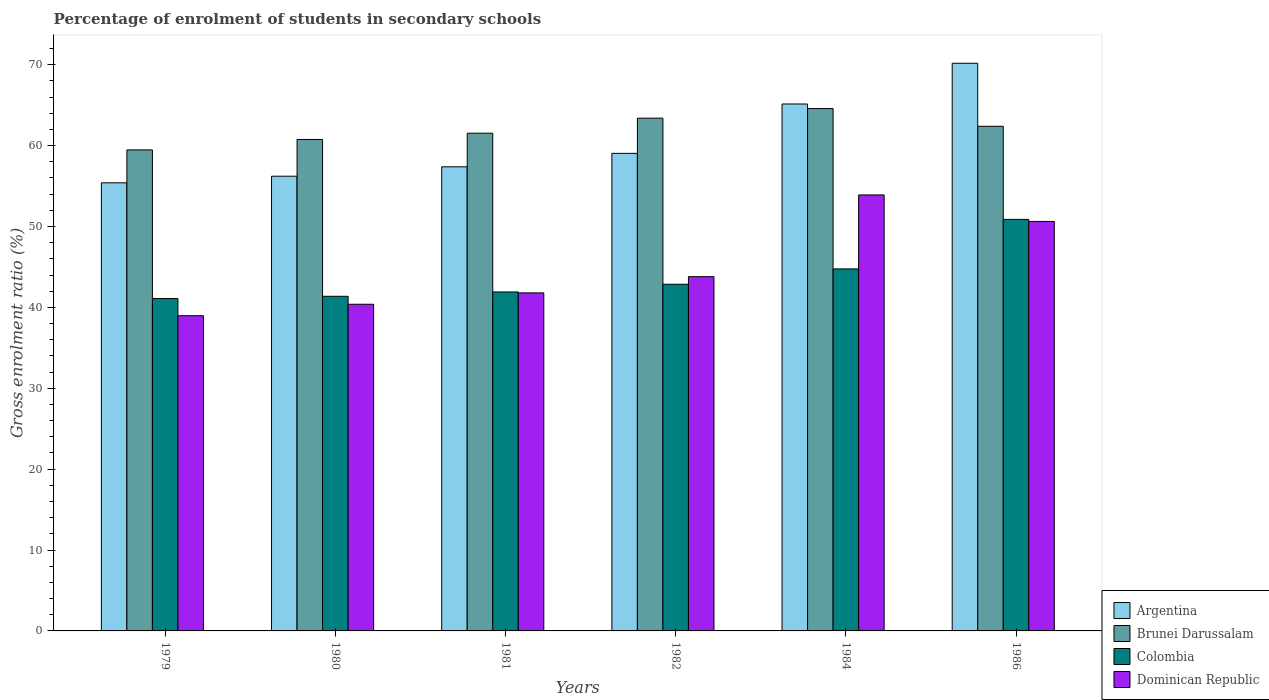How many different coloured bars are there?
Offer a very short reply. 4. Are the number of bars on each tick of the X-axis equal?
Keep it short and to the point. Yes. How many bars are there on the 2nd tick from the left?
Provide a short and direct response. 4. What is the label of the 1st group of bars from the left?
Make the answer very short. 1979. In how many cases, is the number of bars for a given year not equal to the number of legend labels?
Offer a terse response. 0. What is the percentage of students enrolled in secondary schools in Argentina in 1982?
Offer a very short reply. 59.05. Across all years, what is the maximum percentage of students enrolled in secondary schools in Colombia?
Offer a very short reply. 50.88. Across all years, what is the minimum percentage of students enrolled in secondary schools in Brunei Darussalam?
Keep it short and to the point. 59.47. In which year was the percentage of students enrolled in secondary schools in Dominican Republic maximum?
Offer a terse response. 1984. In which year was the percentage of students enrolled in secondary schools in Argentina minimum?
Your answer should be very brief. 1979. What is the total percentage of students enrolled in secondary schools in Argentina in the graph?
Your answer should be very brief. 363.38. What is the difference between the percentage of students enrolled in secondary schools in Brunei Darussalam in 1981 and that in 1984?
Make the answer very short. -3.05. What is the difference between the percentage of students enrolled in secondary schools in Argentina in 1986 and the percentage of students enrolled in secondary schools in Brunei Darussalam in 1980?
Offer a terse response. 9.42. What is the average percentage of students enrolled in secondary schools in Argentina per year?
Give a very brief answer. 60.56. In the year 1984, what is the difference between the percentage of students enrolled in secondary schools in Dominican Republic and percentage of students enrolled in secondary schools in Colombia?
Your answer should be compact. 9.14. What is the ratio of the percentage of students enrolled in secondary schools in Argentina in 1980 to that in 1981?
Keep it short and to the point. 0.98. Is the difference between the percentage of students enrolled in secondary schools in Dominican Republic in 1984 and 1986 greater than the difference between the percentage of students enrolled in secondary schools in Colombia in 1984 and 1986?
Provide a short and direct response. Yes. What is the difference between the highest and the second highest percentage of students enrolled in secondary schools in Dominican Republic?
Make the answer very short. 3.28. What is the difference between the highest and the lowest percentage of students enrolled in secondary schools in Dominican Republic?
Your answer should be very brief. 14.93. In how many years, is the percentage of students enrolled in secondary schools in Colombia greater than the average percentage of students enrolled in secondary schools in Colombia taken over all years?
Provide a short and direct response. 2. Is it the case that in every year, the sum of the percentage of students enrolled in secondary schools in Brunei Darussalam and percentage of students enrolled in secondary schools in Argentina is greater than the sum of percentage of students enrolled in secondary schools in Dominican Republic and percentage of students enrolled in secondary schools in Colombia?
Ensure brevity in your answer.  Yes. What does the 1st bar from the right in 1984 represents?
Give a very brief answer. Dominican Republic. How many bars are there?
Provide a succinct answer. 24. Are all the bars in the graph horizontal?
Give a very brief answer. No. How many years are there in the graph?
Give a very brief answer. 6. Does the graph contain any zero values?
Your answer should be very brief. No. How many legend labels are there?
Provide a short and direct response. 4. How are the legend labels stacked?
Ensure brevity in your answer.  Vertical. What is the title of the graph?
Give a very brief answer. Percentage of enrolment of students in secondary schools. What is the Gross enrolment ratio (%) of Argentina in 1979?
Ensure brevity in your answer.  55.4. What is the Gross enrolment ratio (%) of Brunei Darussalam in 1979?
Your answer should be compact. 59.47. What is the Gross enrolment ratio (%) in Colombia in 1979?
Provide a short and direct response. 41.1. What is the Gross enrolment ratio (%) in Dominican Republic in 1979?
Provide a succinct answer. 38.97. What is the Gross enrolment ratio (%) in Argentina in 1980?
Your answer should be very brief. 56.22. What is the Gross enrolment ratio (%) of Brunei Darussalam in 1980?
Your answer should be very brief. 60.76. What is the Gross enrolment ratio (%) of Colombia in 1980?
Ensure brevity in your answer.  41.37. What is the Gross enrolment ratio (%) in Dominican Republic in 1980?
Make the answer very short. 40.39. What is the Gross enrolment ratio (%) in Argentina in 1981?
Offer a very short reply. 57.38. What is the Gross enrolment ratio (%) of Brunei Darussalam in 1981?
Offer a terse response. 61.54. What is the Gross enrolment ratio (%) in Colombia in 1981?
Offer a terse response. 41.91. What is the Gross enrolment ratio (%) in Dominican Republic in 1981?
Your answer should be compact. 41.79. What is the Gross enrolment ratio (%) of Argentina in 1982?
Your answer should be very brief. 59.05. What is the Gross enrolment ratio (%) in Brunei Darussalam in 1982?
Ensure brevity in your answer.  63.4. What is the Gross enrolment ratio (%) in Colombia in 1982?
Make the answer very short. 42.86. What is the Gross enrolment ratio (%) in Dominican Republic in 1982?
Offer a terse response. 43.8. What is the Gross enrolment ratio (%) of Argentina in 1984?
Provide a succinct answer. 65.15. What is the Gross enrolment ratio (%) in Brunei Darussalam in 1984?
Your response must be concise. 64.59. What is the Gross enrolment ratio (%) in Colombia in 1984?
Keep it short and to the point. 44.76. What is the Gross enrolment ratio (%) of Dominican Republic in 1984?
Offer a terse response. 53.9. What is the Gross enrolment ratio (%) of Argentina in 1986?
Offer a very short reply. 70.18. What is the Gross enrolment ratio (%) of Brunei Darussalam in 1986?
Your answer should be compact. 62.39. What is the Gross enrolment ratio (%) of Colombia in 1986?
Provide a succinct answer. 50.88. What is the Gross enrolment ratio (%) in Dominican Republic in 1986?
Provide a succinct answer. 50.63. Across all years, what is the maximum Gross enrolment ratio (%) of Argentina?
Give a very brief answer. 70.18. Across all years, what is the maximum Gross enrolment ratio (%) in Brunei Darussalam?
Keep it short and to the point. 64.59. Across all years, what is the maximum Gross enrolment ratio (%) of Colombia?
Provide a succinct answer. 50.88. Across all years, what is the maximum Gross enrolment ratio (%) in Dominican Republic?
Make the answer very short. 53.9. Across all years, what is the minimum Gross enrolment ratio (%) of Argentina?
Your answer should be compact. 55.4. Across all years, what is the minimum Gross enrolment ratio (%) in Brunei Darussalam?
Your response must be concise. 59.47. Across all years, what is the minimum Gross enrolment ratio (%) in Colombia?
Make the answer very short. 41.1. Across all years, what is the minimum Gross enrolment ratio (%) in Dominican Republic?
Ensure brevity in your answer.  38.97. What is the total Gross enrolment ratio (%) of Argentina in the graph?
Offer a terse response. 363.38. What is the total Gross enrolment ratio (%) of Brunei Darussalam in the graph?
Give a very brief answer. 372.14. What is the total Gross enrolment ratio (%) of Colombia in the graph?
Your response must be concise. 262.88. What is the total Gross enrolment ratio (%) in Dominican Republic in the graph?
Provide a succinct answer. 269.48. What is the difference between the Gross enrolment ratio (%) in Argentina in 1979 and that in 1980?
Keep it short and to the point. -0.82. What is the difference between the Gross enrolment ratio (%) in Brunei Darussalam in 1979 and that in 1980?
Your response must be concise. -1.29. What is the difference between the Gross enrolment ratio (%) in Colombia in 1979 and that in 1980?
Make the answer very short. -0.28. What is the difference between the Gross enrolment ratio (%) in Dominican Republic in 1979 and that in 1980?
Your answer should be very brief. -1.42. What is the difference between the Gross enrolment ratio (%) in Argentina in 1979 and that in 1981?
Offer a terse response. -1.98. What is the difference between the Gross enrolment ratio (%) in Brunei Darussalam in 1979 and that in 1981?
Your answer should be compact. -2.07. What is the difference between the Gross enrolment ratio (%) in Colombia in 1979 and that in 1981?
Make the answer very short. -0.81. What is the difference between the Gross enrolment ratio (%) of Dominican Republic in 1979 and that in 1981?
Keep it short and to the point. -2.82. What is the difference between the Gross enrolment ratio (%) in Argentina in 1979 and that in 1982?
Offer a very short reply. -3.64. What is the difference between the Gross enrolment ratio (%) in Brunei Darussalam in 1979 and that in 1982?
Make the answer very short. -3.93. What is the difference between the Gross enrolment ratio (%) of Colombia in 1979 and that in 1982?
Offer a very short reply. -1.77. What is the difference between the Gross enrolment ratio (%) of Dominican Republic in 1979 and that in 1982?
Your response must be concise. -4.83. What is the difference between the Gross enrolment ratio (%) of Argentina in 1979 and that in 1984?
Offer a very short reply. -9.74. What is the difference between the Gross enrolment ratio (%) of Brunei Darussalam in 1979 and that in 1984?
Give a very brief answer. -5.12. What is the difference between the Gross enrolment ratio (%) of Colombia in 1979 and that in 1984?
Give a very brief answer. -3.66. What is the difference between the Gross enrolment ratio (%) of Dominican Republic in 1979 and that in 1984?
Keep it short and to the point. -14.93. What is the difference between the Gross enrolment ratio (%) in Argentina in 1979 and that in 1986?
Your response must be concise. -14.78. What is the difference between the Gross enrolment ratio (%) in Brunei Darussalam in 1979 and that in 1986?
Your response must be concise. -2.92. What is the difference between the Gross enrolment ratio (%) of Colombia in 1979 and that in 1986?
Make the answer very short. -9.79. What is the difference between the Gross enrolment ratio (%) of Dominican Republic in 1979 and that in 1986?
Make the answer very short. -11.66. What is the difference between the Gross enrolment ratio (%) of Argentina in 1980 and that in 1981?
Offer a terse response. -1.16. What is the difference between the Gross enrolment ratio (%) in Brunei Darussalam in 1980 and that in 1981?
Make the answer very short. -0.78. What is the difference between the Gross enrolment ratio (%) in Colombia in 1980 and that in 1981?
Keep it short and to the point. -0.53. What is the difference between the Gross enrolment ratio (%) in Dominican Republic in 1980 and that in 1981?
Ensure brevity in your answer.  -1.41. What is the difference between the Gross enrolment ratio (%) of Argentina in 1980 and that in 1982?
Your response must be concise. -2.83. What is the difference between the Gross enrolment ratio (%) of Brunei Darussalam in 1980 and that in 1982?
Offer a terse response. -2.63. What is the difference between the Gross enrolment ratio (%) in Colombia in 1980 and that in 1982?
Your answer should be very brief. -1.49. What is the difference between the Gross enrolment ratio (%) in Dominican Republic in 1980 and that in 1982?
Provide a succinct answer. -3.41. What is the difference between the Gross enrolment ratio (%) in Argentina in 1980 and that in 1984?
Offer a very short reply. -8.93. What is the difference between the Gross enrolment ratio (%) of Brunei Darussalam in 1980 and that in 1984?
Provide a short and direct response. -3.82. What is the difference between the Gross enrolment ratio (%) in Colombia in 1980 and that in 1984?
Your response must be concise. -3.39. What is the difference between the Gross enrolment ratio (%) of Dominican Republic in 1980 and that in 1984?
Make the answer very short. -13.52. What is the difference between the Gross enrolment ratio (%) of Argentina in 1980 and that in 1986?
Provide a short and direct response. -13.96. What is the difference between the Gross enrolment ratio (%) of Brunei Darussalam in 1980 and that in 1986?
Offer a terse response. -1.63. What is the difference between the Gross enrolment ratio (%) of Colombia in 1980 and that in 1986?
Offer a terse response. -9.51. What is the difference between the Gross enrolment ratio (%) of Dominican Republic in 1980 and that in 1986?
Make the answer very short. -10.24. What is the difference between the Gross enrolment ratio (%) of Argentina in 1981 and that in 1982?
Your response must be concise. -1.66. What is the difference between the Gross enrolment ratio (%) of Brunei Darussalam in 1981 and that in 1982?
Provide a short and direct response. -1.86. What is the difference between the Gross enrolment ratio (%) in Colombia in 1981 and that in 1982?
Your response must be concise. -0.96. What is the difference between the Gross enrolment ratio (%) of Dominican Republic in 1981 and that in 1982?
Offer a terse response. -2.01. What is the difference between the Gross enrolment ratio (%) in Argentina in 1981 and that in 1984?
Your response must be concise. -7.77. What is the difference between the Gross enrolment ratio (%) of Brunei Darussalam in 1981 and that in 1984?
Provide a short and direct response. -3.05. What is the difference between the Gross enrolment ratio (%) of Colombia in 1981 and that in 1984?
Make the answer very short. -2.85. What is the difference between the Gross enrolment ratio (%) of Dominican Republic in 1981 and that in 1984?
Keep it short and to the point. -12.11. What is the difference between the Gross enrolment ratio (%) in Argentina in 1981 and that in 1986?
Make the answer very short. -12.8. What is the difference between the Gross enrolment ratio (%) of Brunei Darussalam in 1981 and that in 1986?
Offer a very short reply. -0.85. What is the difference between the Gross enrolment ratio (%) of Colombia in 1981 and that in 1986?
Keep it short and to the point. -8.97. What is the difference between the Gross enrolment ratio (%) in Dominican Republic in 1981 and that in 1986?
Give a very brief answer. -8.83. What is the difference between the Gross enrolment ratio (%) of Argentina in 1982 and that in 1984?
Offer a very short reply. -6.1. What is the difference between the Gross enrolment ratio (%) in Brunei Darussalam in 1982 and that in 1984?
Your response must be concise. -1.19. What is the difference between the Gross enrolment ratio (%) in Colombia in 1982 and that in 1984?
Provide a succinct answer. -1.9. What is the difference between the Gross enrolment ratio (%) of Dominican Republic in 1982 and that in 1984?
Give a very brief answer. -10.11. What is the difference between the Gross enrolment ratio (%) of Argentina in 1982 and that in 1986?
Your response must be concise. -11.14. What is the difference between the Gross enrolment ratio (%) of Colombia in 1982 and that in 1986?
Keep it short and to the point. -8.02. What is the difference between the Gross enrolment ratio (%) of Dominican Republic in 1982 and that in 1986?
Your answer should be compact. -6.83. What is the difference between the Gross enrolment ratio (%) in Argentina in 1984 and that in 1986?
Keep it short and to the point. -5.04. What is the difference between the Gross enrolment ratio (%) of Brunei Darussalam in 1984 and that in 1986?
Your response must be concise. 2.2. What is the difference between the Gross enrolment ratio (%) of Colombia in 1984 and that in 1986?
Your answer should be very brief. -6.12. What is the difference between the Gross enrolment ratio (%) of Dominican Republic in 1984 and that in 1986?
Your answer should be very brief. 3.28. What is the difference between the Gross enrolment ratio (%) in Argentina in 1979 and the Gross enrolment ratio (%) in Brunei Darussalam in 1980?
Your answer should be compact. -5.36. What is the difference between the Gross enrolment ratio (%) in Argentina in 1979 and the Gross enrolment ratio (%) in Colombia in 1980?
Keep it short and to the point. 14.03. What is the difference between the Gross enrolment ratio (%) in Argentina in 1979 and the Gross enrolment ratio (%) in Dominican Republic in 1980?
Your answer should be very brief. 15.02. What is the difference between the Gross enrolment ratio (%) of Brunei Darussalam in 1979 and the Gross enrolment ratio (%) of Colombia in 1980?
Keep it short and to the point. 18.1. What is the difference between the Gross enrolment ratio (%) of Brunei Darussalam in 1979 and the Gross enrolment ratio (%) of Dominican Republic in 1980?
Provide a succinct answer. 19.08. What is the difference between the Gross enrolment ratio (%) in Colombia in 1979 and the Gross enrolment ratio (%) in Dominican Republic in 1980?
Make the answer very short. 0.71. What is the difference between the Gross enrolment ratio (%) of Argentina in 1979 and the Gross enrolment ratio (%) of Brunei Darussalam in 1981?
Your answer should be compact. -6.14. What is the difference between the Gross enrolment ratio (%) of Argentina in 1979 and the Gross enrolment ratio (%) of Colombia in 1981?
Your answer should be very brief. 13.5. What is the difference between the Gross enrolment ratio (%) in Argentina in 1979 and the Gross enrolment ratio (%) in Dominican Republic in 1981?
Your answer should be compact. 13.61. What is the difference between the Gross enrolment ratio (%) in Brunei Darussalam in 1979 and the Gross enrolment ratio (%) in Colombia in 1981?
Your answer should be compact. 17.56. What is the difference between the Gross enrolment ratio (%) of Brunei Darussalam in 1979 and the Gross enrolment ratio (%) of Dominican Republic in 1981?
Ensure brevity in your answer.  17.68. What is the difference between the Gross enrolment ratio (%) in Colombia in 1979 and the Gross enrolment ratio (%) in Dominican Republic in 1981?
Your answer should be very brief. -0.7. What is the difference between the Gross enrolment ratio (%) of Argentina in 1979 and the Gross enrolment ratio (%) of Brunei Darussalam in 1982?
Your answer should be compact. -7.99. What is the difference between the Gross enrolment ratio (%) in Argentina in 1979 and the Gross enrolment ratio (%) in Colombia in 1982?
Your answer should be very brief. 12.54. What is the difference between the Gross enrolment ratio (%) in Argentina in 1979 and the Gross enrolment ratio (%) in Dominican Republic in 1982?
Provide a succinct answer. 11.61. What is the difference between the Gross enrolment ratio (%) in Brunei Darussalam in 1979 and the Gross enrolment ratio (%) in Colombia in 1982?
Your answer should be very brief. 16.61. What is the difference between the Gross enrolment ratio (%) in Brunei Darussalam in 1979 and the Gross enrolment ratio (%) in Dominican Republic in 1982?
Ensure brevity in your answer.  15.67. What is the difference between the Gross enrolment ratio (%) of Colombia in 1979 and the Gross enrolment ratio (%) of Dominican Republic in 1982?
Offer a terse response. -2.7. What is the difference between the Gross enrolment ratio (%) of Argentina in 1979 and the Gross enrolment ratio (%) of Brunei Darussalam in 1984?
Provide a short and direct response. -9.18. What is the difference between the Gross enrolment ratio (%) in Argentina in 1979 and the Gross enrolment ratio (%) in Colombia in 1984?
Offer a terse response. 10.64. What is the difference between the Gross enrolment ratio (%) in Argentina in 1979 and the Gross enrolment ratio (%) in Dominican Republic in 1984?
Ensure brevity in your answer.  1.5. What is the difference between the Gross enrolment ratio (%) of Brunei Darussalam in 1979 and the Gross enrolment ratio (%) of Colombia in 1984?
Provide a short and direct response. 14.71. What is the difference between the Gross enrolment ratio (%) in Brunei Darussalam in 1979 and the Gross enrolment ratio (%) in Dominican Republic in 1984?
Your answer should be compact. 5.56. What is the difference between the Gross enrolment ratio (%) in Colombia in 1979 and the Gross enrolment ratio (%) in Dominican Republic in 1984?
Provide a succinct answer. -12.81. What is the difference between the Gross enrolment ratio (%) of Argentina in 1979 and the Gross enrolment ratio (%) of Brunei Darussalam in 1986?
Your response must be concise. -6.99. What is the difference between the Gross enrolment ratio (%) of Argentina in 1979 and the Gross enrolment ratio (%) of Colombia in 1986?
Give a very brief answer. 4.52. What is the difference between the Gross enrolment ratio (%) of Argentina in 1979 and the Gross enrolment ratio (%) of Dominican Republic in 1986?
Ensure brevity in your answer.  4.78. What is the difference between the Gross enrolment ratio (%) in Brunei Darussalam in 1979 and the Gross enrolment ratio (%) in Colombia in 1986?
Provide a short and direct response. 8.59. What is the difference between the Gross enrolment ratio (%) of Brunei Darussalam in 1979 and the Gross enrolment ratio (%) of Dominican Republic in 1986?
Give a very brief answer. 8.84. What is the difference between the Gross enrolment ratio (%) of Colombia in 1979 and the Gross enrolment ratio (%) of Dominican Republic in 1986?
Make the answer very short. -9.53. What is the difference between the Gross enrolment ratio (%) of Argentina in 1980 and the Gross enrolment ratio (%) of Brunei Darussalam in 1981?
Offer a very short reply. -5.32. What is the difference between the Gross enrolment ratio (%) in Argentina in 1980 and the Gross enrolment ratio (%) in Colombia in 1981?
Your answer should be very brief. 14.31. What is the difference between the Gross enrolment ratio (%) in Argentina in 1980 and the Gross enrolment ratio (%) in Dominican Republic in 1981?
Your answer should be compact. 14.43. What is the difference between the Gross enrolment ratio (%) in Brunei Darussalam in 1980 and the Gross enrolment ratio (%) in Colombia in 1981?
Provide a short and direct response. 18.85. What is the difference between the Gross enrolment ratio (%) of Brunei Darussalam in 1980 and the Gross enrolment ratio (%) of Dominican Republic in 1981?
Provide a short and direct response. 18.97. What is the difference between the Gross enrolment ratio (%) in Colombia in 1980 and the Gross enrolment ratio (%) in Dominican Republic in 1981?
Give a very brief answer. -0.42. What is the difference between the Gross enrolment ratio (%) of Argentina in 1980 and the Gross enrolment ratio (%) of Brunei Darussalam in 1982?
Ensure brevity in your answer.  -7.18. What is the difference between the Gross enrolment ratio (%) in Argentina in 1980 and the Gross enrolment ratio (%) in Colombia in 1982?
Offer a very short reply. 13.36. What is the difference between the Gross enrolment ratio (%) in Argentina in 1980 and the Gross enrolment ratio (%) in Dominican Republic in 1982?
Your answer should be very brief. 12.42. What is the difference between the Gross enrolment ratio (%) of Brunei Darussalam in 1980 and the Gross enrolment ratio (%) of Colombia in 1982?
Make the answer very short. 17.9. What is the difference between the Gross enrolment ratio (%) in Brunei Darussalam in 1980 and the Gross enrolment ratio (%) in Dominican Republic in 1982?
Make the answer very short. 16.96. What is the difference between the Gross enrolment ratio (%) of Colombia in 1980 and the Gross enrolment ratio (%) of Dominican Republic in 1982?
Make the answer very short. -2.43. What is the difference between the Gross enrolment ratio (%) of Argentina in 1980 and the Gross enrolment ratio (%) of Brunei Darussalam in 1984?
Your answer should be very brief. -8.37. What is the difference between the Gross enrolment ratio (%) of Argentina in 1980 and the Gross enrolment ratio (%) of Colombia in 1984?
Your answer should be compact. 11.46. What is the difference between the Gross enrolment ratio (%) in Argentina in 1980 and the Gross enrolment ratio (%) in Dominican Republic in 1984?
Offer a terse response. 2.31. What is the difference between the Gross enrolment ratio (%) of Brunei Darussalam in 1980 and the Gross enrolment ratio (%) of Colombia in 1984?
Offer a terse response. 16. What is the difference between the Gross enrolment ratio (%) of Brunei Darussalam in 1980 and the Gross enrolment ratio (%) of Dominican Republic in 1984?
Ensure brevity in your answer.  6.86. What is the difference between the Gross enrolment ratio (%) in Colombia in 1980 and the Gross enrolment ratio (%) in Dominican Republic in 1984?
Offer a very short reply. -12.53. What is the difference between the Gross enrolment ratio (%) of Argentina in 1980 and the Gross enrolment ratio (%) of Brunei Darussalam in 1986?
Your answer should be compact. -6.17. What is the difference between the Gross enrolment ratio (%) in Argentina in 1980 and the Gross enrolment ratio (%) in Colombia in 1986?
Your answer should be compact. 5.34. What is the difference between the Gross enrolment ratio (%) in Argentina in 1980 and the Gross enrolment ratio (%) in Dominican Republic in 1986?
Provide a succinct answer. 5.59. What is the difference between the Gross enrolment ratio (%) of Brunei Darussalam in 1980 and the Gross enrolment ratio (%) of Colombia in 1986?
Provide a succinct answer. 9.88. What is the difference between the Gross enrolment ratio (%) of Brunei Darussalam in 1980 and the Gross enrolment ratio (%) of Dominican Republic in 1986?
Offer a very short reply. 10.14. What is the difference between the Gross enrolment ratio (%) in Colombia in 1980 and the Gross enrolment ratio (%) in Dominican Republic in 1986?
Provide a short and direct response. -9.25. What is the difference between the Gross enrolment ratio (%) of Argentina in 1981 and the Gross enrolment ratio (%) of Brunei Darussalam in 1982?
Provide a succinct answer. -6.01. What is the difference between the Gross enrolment ratio (%) in Argentina in 1981 and the Gross enrolment ratio (%) in Colombia in 1982?
Give a very brief answer. 14.52. What is the difference between the Gross enrolment ratio (%) of Argentina in 1981 and the Gross enrolment ratio (%) of Dominican Republic in 1982?
Your answer should be very brief. 13.58. What is the difference between the Gross enrolment ratio (%) in Brunei Darussalam in 1981 and the Gross enrolment ratio (%) in Colombia in 1982?
Keep it short and to the point. 18.68. What is the difference between the Gross enrolment ratio (%) in Brunei Darussalam in 1981 and the Gross enrolment ratio (%) in Dominican Republic in 1982?
Give a very brief answer. 17.74. What is the difference between the Gross enrolment ratio (%) in Colombia in 1981 and the Gross enrolment ratio (%) in Dominican Republic in 1982?
Ensure brevity in your answer.  -1.89. What is the difference between the Gross enrolment ratio (%) in Argentina in 1981 and the Gross enrolment ratio (%) in Brunei Darussalam in 1984?
Make the answer very short. -7.2. What is the difference between the Gross enrolment ratio (%) of Argentina in 1981 and the Gross enrolment ratio (%) of Colombia in 1984?
Provide a short and direct response. 12.62. What is the difference between the Gross enrolment ratio (%) of Argentina in 1981 and the Gross enrolment ratio (%) of Dominican Republic in 1984?
Offer a terse response. 3.48. What is the difference between the Gross enrolment ratio (%) of Brunei Darussalam in 1981 and the Gross enrolment ratio (%) of Colombia in 1984?
Ensure brevity in your answer.  16.78. What is the difference between the Gross enrolment ratio (%) of Brunei Darussalam in 1981 and the Gross enrolment ratio (%) of Dominican Republic in 1984?
Provide a succinct answer. 7.63. What is the difference between the Gross enrolment ratio (%) in Colombia in 1981 and the Gross enrolment ratio (%) in Dominican Republic in 1984?
Offer a terse response. -12. What is the difference between the Gross enrolment ratio (%) of Argentina in 1981 and the Gross enrolment ratio (%) of Brunei Darussalam in 1986?
Provide a succinct answer. -5.01. What is the difference between the Gross enrolment ratio (%) in Argentina in 1981 and the Gross enrolment ratio (%) in Colombia in 1986?
Your response must be concise. 6.5. What is the difference between the Gross enrolment ratio (%) of Argentina in 1981 and the Gross enrolment ratio (%) of Dominican Republic in 1986?
Offer a very short reply. 6.76. What is the difference between the Gross enrolment ratio (%) of Brunei Darussalam in 1981 and the Gross enrolment ratio (%) of Colombia in 1986?
Provide a short and direct response. 10.66. What is the difference between the Gross enrolment ratio (%) of Brunei Darussalam in 1981 and the Gross enrolment ratio (%) of Dominican Republic in 1986?
Offer a very short reply. 10.91. What is the difference between the Gross enrolment ratio (%) in Colombia in 1981 and the Gross enrolment ratio (%) in Dominican Republic in 1986?
Give a very brief answer. -8.72. What is the difference between the Gross enrolment ratio (%) of Argentina in 1982 and the Gross enrolment ratio (%) of Brunei Darussalam in 1984?
Give a very brief answer. -5.54. What is the difference between the Gross enrolment ratio (%) of Argentina in 1982 and the Gross enrolment ratio (%) of Colombia in 1984?
Your answer should be compact. 14.29. What is the difference between the Gross enrolment ratio (%) in Argentina in 1982 and the Gross enrolment ratio (%) in Dominican Republic in 1984?
Keep it short and to the point. 5.14. What is the difference between the Gross enrolment ratio (%) in Brunei Darussalam in 1982 and the Gross enrolment ratio (%) in Colombia in 1984?
Provide a succinct answer. 18.64. What is the difference between the Gross enrolment ratio (%) of Brunei Darussalam in 1982 and the Gross enrolment ratio (%) of Dominican Republic in 1984?
Offer a terse response. 9.49. What is the difference between the Gross enrolment ratio (%) in Colombia in 1982 and the Gross enrolment ratio (%) in Dominican Republic in 1984?
Ensure brevity in your answer.  -11.04. What is the difference between the Gross enrolment ratio (%) of Argentina in 1982 and the Gross enrolment ratio (%) of Brunei Darussalam in 1986?
Offer a very short reply. -3.34. What is the difference between the Gross enrolment ratio (%) of Argentina in 1982 and the Gross enrolment ratio (%) of Colombia in 1986?
Your answer should be very brief. 8.16. What is the difference between the Gross enrolment ratio (%) in Argentina in 1982 and the Gross enrolment ratio (%) in Dominican Republic in 1986?
Make the answer very short. 8.42. What is the difference between the Gross enrolment ratio (%) in Brunei Darussalam in 1982 and the Gross enrolment ratio (%) in Colombia in 1986?
Give a very brief answer. 12.51. What is the difference between the Gross enrolment ratio (%) of Brunei Darussalam in 1982 and the Gross enrolment ratio (%) of Dominican Republic in 1986?
Keep it short and to the point. 12.77. What is the difference between the Gross enrolment ratio (%) in Colombia in 1982 and the Gross enrolment ratio (%) in Dominican Republic in 1986?
Make the answer very short. -7.76. What is the difference between the Gross enrolment ratio (%) of Argentina in 1984 and the Gross enrolment ratio (%) of Brunei Darussalam in 1986?
Ensure brevity in your answer.  2.76. What is the difference between the Gross enrolment ratio (%) of Argentina in 1984 and the Gross enrolment ratio (%) of Colombia in 1986?
Your answer should be compact. 14.27. What is the difference between the Gross enrolment ratio (%) in Argentina in 1984 and the Gross enrolment ratio (%) in Dominican Republic in 1986?
Your answer should be very brief. 14.52. What is the difference between the Gross enrolment ratio (%) in Brunei Darussalam in 1984 and the Gross enrolment ratio (%) in Colombia in 1986?
Offer a very short reply. 13.7. What is the difference between the Gross enrolment ratio (%) of Brunei Darussalam in 1984 and the Gross enrolment ratio (%) of Dominican Republic in 1986?
Offer a terse response. 13.96. What is the difference between the Gross enrolment ratio (%) in Colombia in 1984 and the Gross enrolment ratio (%) in Dominican Republic in 1986?
Your response must be concise. -5.87. What is the average Gross enrolment ratio (%) in Argentina per year?
Keep it short and to the point. 60.56. What is the average Gross enrolment ratio (%) of Brunei Darussalam per year?
Ensure brevity in your answer.  62.02. What is the average Gross enrolment ratio (%) of Colombia per year?
Ensure brevity in your answer.  43.81. What is the average Gross enrolment ratio (%) of Dominican Republic per year?
Give a very brief answer. 44.91. In the year 1979, what is the difference between the Gross enrolment ratio (%) of Argentina and Gross enrolment ratio (%) of Brunei Darussalam?
Offer a terse response. -4.07. In the year 1979, what is the difference between the Gross enrolment ratio (%) of Argentina and Gross enrolment ratio (%) of Colombia?
Your response must be concise. 14.31. In the year 1979, what is the difference between the Gross enrolment ratio (%) of Argentina and Gross enrolment ratio (%) of Dominican Republic?
Your answer should be compact. 16.43. In the year 1979, what is the difference between the Gross enrolment ratio (%) in Brunei Darussalam and Gross enrolment ratio (%) in Colombia?
Keep it short and to the point. 18.37. In the year 1979, what is the difference between the Gross enrolment ratio (%) in Brunei Darussalam and Gross enrolment ratio (%) in Dominican Republic?
Ensure brevity in your answer.  20.5. In the year 1979, what is the difference between the Gross enrolment ratio (%) of Colombia and Gross enrolment ratio (%) of Dominican Republic?
Ensure brevity in your answer.  2.13. In the year 1980, what is the difference between the Gross enrolment ratio (%) of Argentina and Gross enrolment ratio (%) of Brunei Darussalam?
Offer a very short reply. -4.54. In the year 1980, what is the difference between the Gross enrolment ratio (%) in Argentina and Gross enrolment ratio (%) in Colombia?
Provide a short and direct response. 14.85. In the year 1980, what is the difference between the Gross enrolment ratio (%) of Argentina and Gross enrolment ratio (%) of Dominican Republic?
Your answer should be very brief. 15.83. In the year 1980, what is the difference between the Gross enrolment ratio (%) in Brunei Darussalam and Gross enrolment ratio (%) in Colombia?
Ensure brevity in your answer.  19.39. In the year 1980, what is the difference between the Gross enrolment ratio (%) of Brunei Darussalam and Gross enrolment ratio (%) of Dominican Republic?
Ensure brevity in your answer.  20.37. In the year 1980, what is the difference between the Gross enrolment ratio (%) in Colombia and Gross enrolment ratio (%) in Dominican Republic?
Provide a succinct answer. 0.98. In the year 1981, what is the difference between the Gross enrolment ratio (%) in Argentina and Gross enrolment ratio (%) in Brunei Darussalam?
Your response must be concise. -4.16. In the year 1981, what is the difference between the Gross enrolment ratio (%) in Argentina and Gross enrolment ratio (%) in Colombia?
Your response must be concise. 15.47. In the year 1981, what is the difference between the Gross enrolment ratio (%) in Argentina and Gross enrolment ratio (%) in Dominican Republic?
Offer a terse response. 15.59. In the year 1981, what is the difference between the Gross enrolment ratio (%) in Brunei Darussalam and Gross enrolment ratio (%) in Colombia?
Give a very brief answer. 19.63. In the year 1981, what is the difference between the Gross enrolment ratio (%) in Brunei Darussalam and Gross enrolment ratio (%) in Dominican Republic?
Provide a succinct answer. 19.75. In the year 1981, what is the difference between the Gross enrolment ratio (%) of Colombia and Gross enrolment ratio (%) of Dominican Republic?
Provide a short and direct response. 0.11. In the year 1982, what is the difference between the Gross enrolment ratio (%) of Argentina and Gross enrolment ratio (%) of Brunei Darussalam?
Make the answer very short. -4.35. In the year 1982, what is the difference between the Gross enrolment ratio (%) in Argentina and Gross enrolment ratio (%) in Colombia?
Make the answer very short. 16.18. In the year 1982, what is the difference between the Gross enrolment ratio (%) in Argentina and Gross enrolment ratio (%) in Dominican Republic?
Your response must be concise. 15.25. In the year 1982, what is the difference between the Gross enrolment ratio (%) in Brunei Darussalam and Gross enrolment ratio (%) in Colombia?
Your response must be concise. 20.53. In the year 1982, what is the difference between the Gross enrolment ratio (%) of Brunei Darussalam and Gross enrolment ratio (%) of Dominican Republic?
Provide a succinct answer. 19.6. In the year 1982, what is the difference between the Gross enrolment ratio (%) in Colombia and Gross enrolment ratio (%) in Dominican Republic?
Your response must be concise. -0.94. In the year 1984, what is the difference between the Gross enrolment ratio (%) in Argentina and Gross enrolment ratio (%) in Brunei Darussalam?
Provide a short and direct response. 0.56. In the year 1984, what is the difference between the Gross enrolment ratio (%) in Argentina and Gross enrolment ratio (%) in Colombia?
Your response must be concise. 20.39. In the year 1984, what is the difference between the Gross enrolment ratio (%) in Argentina and Gross enrolment ratio (%) in Dominican Republic?
Offer a terse response. 11.24. In the year 1984, what is the difference between the Gross enrolment ratio (%) in Brunei Darussalam and Gross enrolment ratio (%) in Colombia?
Make the answer very short. 19.83. In the year 1984, what is the difference between the Gross enrolment ratio (%) in Brunei Darussalam and Gross enrolment ratio (%) in Dominican Republic?
Provide a succinct answer. 10.68. In the year 1984, what is the difference between the Gross enrolment ratio (%) in Colombia and Gross enrolment ratio (%) in Dominican Republic?
Your answer should be very brief. -9.14. In the year 1986, what is the difference between the Gross enrolment ratio (%) of Argentina and Gross enrolment ratio (%) of Brunei Darussalam?
Provide a succinct answer. 7.79. In the year 1986, what is the difference between the Gross enrolment ratio (%) of Argentina and Gross enrolment ratio (%) of Colombia?
Your answer should be compact. 19.3. In the year 1986, what is the difference between the Gross enrolment ratio (%) in Argentina and Gross enrolment ratio (%) in Dominican Republic?
Make the answer very short. 19.56. In the year 1986, what is the difference between the Gross enrolment ratio (%) in Brunei Darussalam and Gross enrolment ratio (%) in Colombia?
Make the answer very short. 11.51. In the year 1986, what is the difference between the Gross enrolment ratio (%) of Brunei Darussalam and Gross enrolment ratio (%) of Dominican Republic?
Make the answer very short. 11.76. In the year 1986, what is the difference between the Gross enrolment ratio (%) of Colombia and Gross enrolment ratio (%) of Dominican Republic?
Provide a succinct answer. 0.26. What is the ratio of the Gross enrolment ratio (%) in Argentina in 1979 to that in 1980?
Give a very brief answer. 0.99. What is the ratio of the Gross enrolment ratio (%) in Brunei Darussalam in 1979 to that in 1980?
Provide a short and direct response. 0.98. What is the ratio of the Gross enrolment ratio (%) of Dominican Republic in 1979 to that in 1980?
Provide a succinct answer. 0.96. What is the ratio of the Gross enrolment ratio (%) of Argentina in 1979 to that in 1981?
Ensure brevity in your answer.  0.97. What is the ratio of the Gross enrolment ratio (%) of Brunei Darussalam in 1979 to that in 1981?
Give a very brief answer. 0.97. What is the ratio of the Gross enrolment ratio (%) in Colombia in 1979 to that in 1981?
Provide a succinct answer. 0.98. What is the ratio of the Gross enrolment ratio (%) of Dominican Republic in 1979 to that in 1981?
Your answer should be compact. 0.93. What is the ratio of the Gross enrolment ratio (%) in Argentina in 1979 to that in 1982?
Offer a terse response. 0.94. What is the ratio of the Gross enrolment ratio (%) in Brunei Darussalam in 1979 to that in 1982?
Offer a terse response. 0.94. What is the ratio of the Gross enrolment ratio (%) of Colombia in 1979 to that in 1982?
Provide a succinct answer. 0.96. What is the ratio of the Gross enrolment ratio (%) in Dominican Republic in 1979 to that in 1982?
Keep it short and to the point. 0.89. What is the ratio of the Gross enrolment ratio (%) in Argentina in 1979 to that in 1984?
Keep it short and to the point. 0.85. What is the ratio of the Gross enrolment ratio (%) in Brunei Darussalam in 1979 to that in 1984?
Make the answer very short. 0.92. What is the ratio of the Gross enrolment ratio (%) in Colombia in 1979 to that in 1984?
Give a very brief answer. 0.92. What is the ratio of the Gross enrolment ratio (%) of Dominican Republic in 1979 to that in 1984?
Offer a very short reply. 0.72. What is the ratio of the Gross enrolment ratio (%) of Argentina in 1979 to that in 1986?
Make the answer very short. 0.79. What is the ratio of the Gross enrolment ratio (%) in Brunei Darussalam in 1979 to that in 1986?
Provide a short and direct response. 0.95. What is the ratio of the Gross enrolment ratio (%) of Colombia in 1979 to that in 1986?
Give a very brief answer. 0.81. What is the ratio of the Gross enrolment ratio (%) of Dominican Republic in 1979 to that in 1986?
Make the answer very short. 0.77. What is the ratio of the Gross enrolment ratio (%) in Argentina in 1980 to that in 1981?
Offer a very short reply. 0.98. What is the ratio of the Gross enrolment ratio (%) in Brunei Darussalam in 1980 to that in 1981?
Keep it short and to the point. 0.99. What is the ratio of the Gross enrolment ratio (%) in Colombia in 1980 to that in 1981?
Keep it short and to the point. 0.99. What is the ratio of the Gross enrolment ratio (%) of Dominican Republic in 1980 to that in 1981?
Keep it short and to the point. 0.97. What is the ratio of the Gross enrolment ratio (%) of Argentina in 1980 to that in 1982?
Give a very brief answer. 0.95. What is the ratio of the Gross enrolment ratio (%) of Brunei Darussalam in 1980 to that in 1982?
Offer a terse response. 0.96. What is the ratio of the Gross enrolment ratio (%) in Colombia in 1980 to that in 1982?
Ensure brevity in your answer.  0.97. What is the ratio of the Gross enrolment ratio (%) in Dominican Republic in 1980 to that in 1982?
Keep it short and to the point. 0.92. What is the ratio of the Gross enrolment ratio (%) in Argentina in 1980 to that in 1984?
Provide a short and direct response. 0.86. What is the ratio of the Gross enrolment ratio (%) of Brunei Darussalam in 1980 to that in 1984?
Your answer should be very brief. 0.94. What is the ratio of the Gross enrolment ratio (%) in Colombia in 1980 to that in 1984?
Offer a terse response. 0.92. What is the ratio of the Gross enrolment ratio (%) in Dominican Republic in 1980 to that in 1984?
Ensure brevity in your answer.  0.75. What is the ratio of the Gross enrolment ratio (%) in Argentina in 1980 to that in 1986?
Offer a terse response. 0.8. What is the ratio of the Gross enrolment ratio (%) of Brunei Darussalam in 1980 to that in 1986?
Your response must be concise. 0.97. What is the ratio of the Gross enrolment ratio (%) in Colombia in 1980 to that in 1986?
Give a very brief answer. 0.81. What is the ratio of the Gross enrolment ratio (%) of Dominican Republic in 1980 to that in 1986?
Provide a succinct answer. 0.8. What is the ratio of the Gross enrolment ratio (%) of Argentina in 1981 to that in 1982?
Offer a very short reply. 0.97. What is the ratio of the Gross enrolment ratio (%) of Brunei Darussalam in 1981 to that in 1982?
Your response must be concise. 0.97. What is the ratio of the Gross enrolment ratio (%) of Colombia in 1981 to that in 1982?
Provide a short and direct response. 0.98. What is the ratio of the Gross enrolment ratio (%) in Dominican Republic in 1981 to that in 1982?
Provide a short and direct response. 0.95. What is the ratio of the Gross enrolment ratio (%) in Argentina in 1981 to that in 1984?
Offer a terse response. 0.88. What is the ratio of the Gross enrolment ratio (%) of Brunei Darussalam in 1981 to that in 1984?
Your answer should be very brief. 0.95. What is the ratio of the Gross enrolment ratio (%) of Colombia in 1981 to that in 1984?
Keep it short and to the point. 0.94. What is the ratio of the Gross enrolment ratio (%) in Dominican Republic in 1981 to that in 1984?
Keep it short and to the point. 0.78. What is the ratio of the Gross enrolment ratio (%) of Argentina in 1981 to that in 1986?
Your response must be concise. 0.82. What is the ratio of the Gross enrolment ratio (%) of Brunei Darussalam in 1981 to that in 1986?
Provide a succinct answer. 0.99. What is the ratio of the Gross enrolment ratio (%) in Colombia in 1981 to that in 1986?
Your answer should be very brief. 0.82. What is the ratio of the Gross enrolment ratio (%) in Dominican Republic in 1981 to that in 1986?
Keep it short and to the point. 0.83. What is the ratio of the Gross enrolment ratio (%) in Argentina in 1982 to that in 1984?
Offer a terse response. 0.91. What is the ratio of the Gross enrolment ratio (%) of Brunei Darussalam in 1982 to that in 1984?
Your answer should be very brief. 0.98. What is the ratio of the Gross enrolment ratio (%) of Colombia in 1982 to that in 1984?
Offer a very short reply. 0.96. What is the ratio of the Gross enrolment ratio (%) of Dominican Republic in 1982 to that in 1984?
Provide a succinct answer. 0.81. What is the ratio of the Gross enrolment ratio (%) in Argentina in 1982 to that in 1986?
Make the answer very short. 0.84. What is the ratio of the Gross enrolment ratio (%) in Brunei Darussalam in 1982 to that in 1986?
Ensure brevity in your answer.  1.02. What is the ratio of the Gross enrolment ratio (%) of Colombia in 1982 to that in 1986?
Provide a short and direct response. 0.84. What is the ratio of the Gross enrolment ratio (%) in Dominican Republic in 1982 to that in 1986?
Your answer should be compact. 0.87. What is the ratio of the Gross enrolment ratio (%) of Argentina in 1984 to that in 1986?
Offer a terse response. 0.93. What is the ratio of the Gross enrolment ratio (%) in Brunei Darussalam in 1984 to that in 1986?
Make the answer very short. 1.04. What is the ratio of the Gross enrolment ratio (%) in Colombia in 1984 to that in 1986?
Provide a succinct answer. 0.88. What is the ratio of the Gross enrolment ratio (%) of Dominican Republic in 1984 to that in 1986?
Your answer should be very brief. 1.06. What is the difference between the highest and the second highest Gross enrolment ratio (%) of Argentina?
Your response must be concise. 5.04. What is the difference between the highest and the second highest Gross enrolment ratio (%) in Brunei Darussalam?
Give a very brief answer. 1.19. What is the difference between the highest and the second highest Gross enrolment ratio (%) in Colombia?
Provide a succinct answer. 6.12. What is the difference between the highest and the second highest Gross enrolment ratio (%) of Dominican Republic?
Keep it short and to the point. 3.28. What is the difference between the highest and the lowest Gross enrolment ratio (%) in Argentina?
Provide a short and direct response. 14.78. What is the difference between the highest and the lowest Gross enrolment ratio (%) in Brunei Darussalam?
Keep it short and to the point. 5.12. What is the difference between the highest and the lowest Gross enrolment ratio (%) in Colombia?
Your answer should be very brief. 9.79. What is the difference between the highest and the lowest Gross enrolment ratio (%) of Dominican Republic?
Your response must be concise. 14.93. 